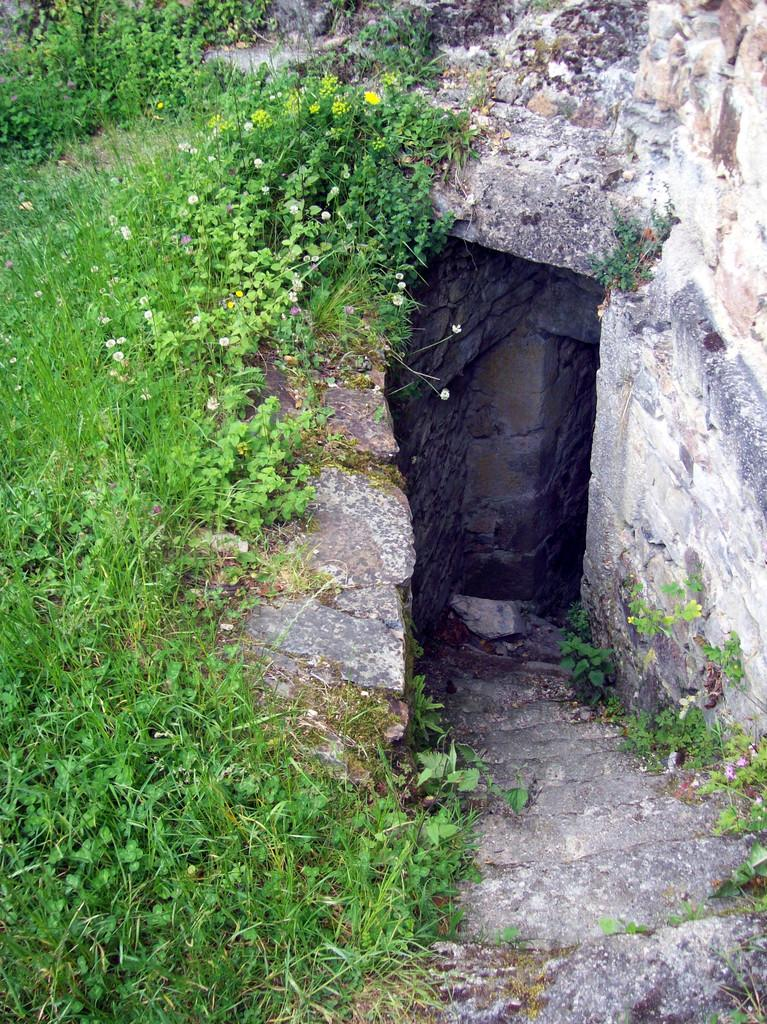What type of natural formation is present in the image? There is a cave in the image. What type of vegetation can be seen on the left side of the image? There is grass on the left side of the image. What type of transportation is visible in the image? There is no transportation visible in the image; it only features a cave and grass. Can you see a friend in the image? There is no friend present in the image; it only features a cave and grass. 